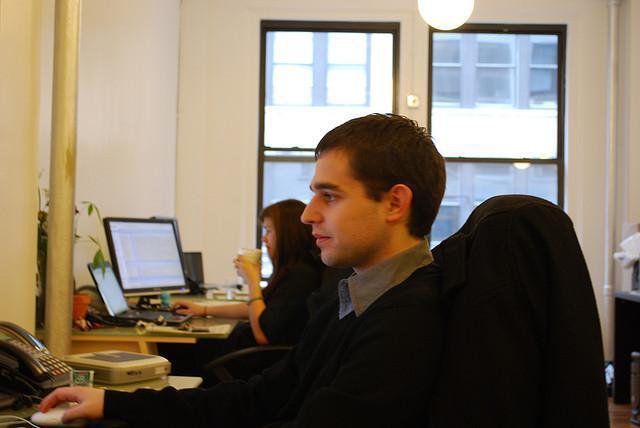How many windows are there?
Give a very brief answer. 2. How many people are in the photo?
Give a very brief answer. 2. How many people are there?
Give a very brief answer. 2. 